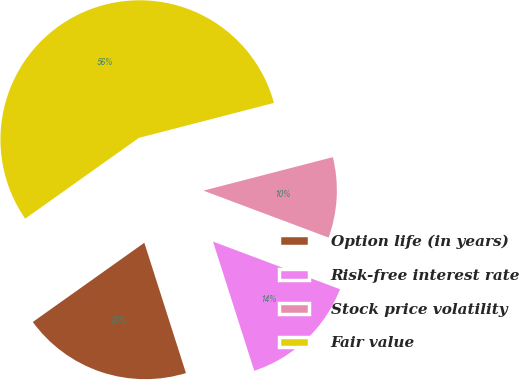Convert chart to OTSL. <chart><loc_0><loc_0><loc_500><loc_500><pie_chart><fcel>Option life (in years)<fcel>Risk-free interest rate<fcel>Stock price volatility<fcel>Fair value<nl><fcel>20.09%<fcel>14.37%<fcel>9.74%<fcel>55.8%<nl></chart> 